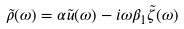Convert formula to latex. <formula><loc_0><loc_0><loc_500><loc_500>\tilde { \rho } ( \omega ) = \alpha \tilde { u } ( \omega ) - i \omega \beta _ { 1 } \tilde { \zeta } ( \omega )</formula> 